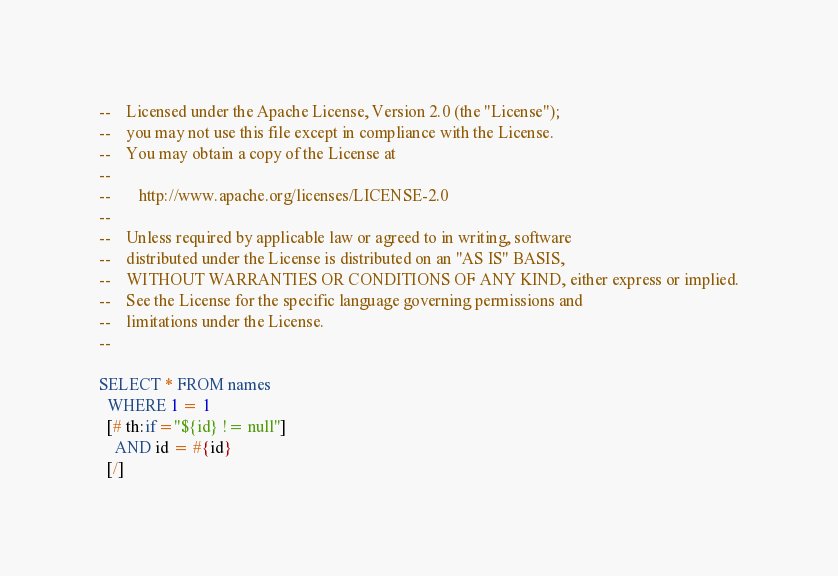Convert code to text. <code><loc_0><loc_0><loc_500><loc_500><_SQL_>--    Licensed under the Apache License, Version 2.0 (the "License");
--    you may not use this file except in compliance with the License.
--    You may obtain a copy of the License at
--
--       http://www.apache.org/licenses/LICENSE-2.0
--
--    Unless required by applicable law or agreed to in writing, software
--    distributed under the License is distributed on an "AS IS" BASIS,
--    WITHOUT WARRANTIES OR CONDITIONS OF ANY KIND, either express or implied.
--    See the License for the specific language governing permissions and
--    limitations under the License.
--

SELECT * FROM names
  WHERE 1 = 1
  [# th:if="${id} != null"]
    AND id = #{id}
  [/]
</code> 